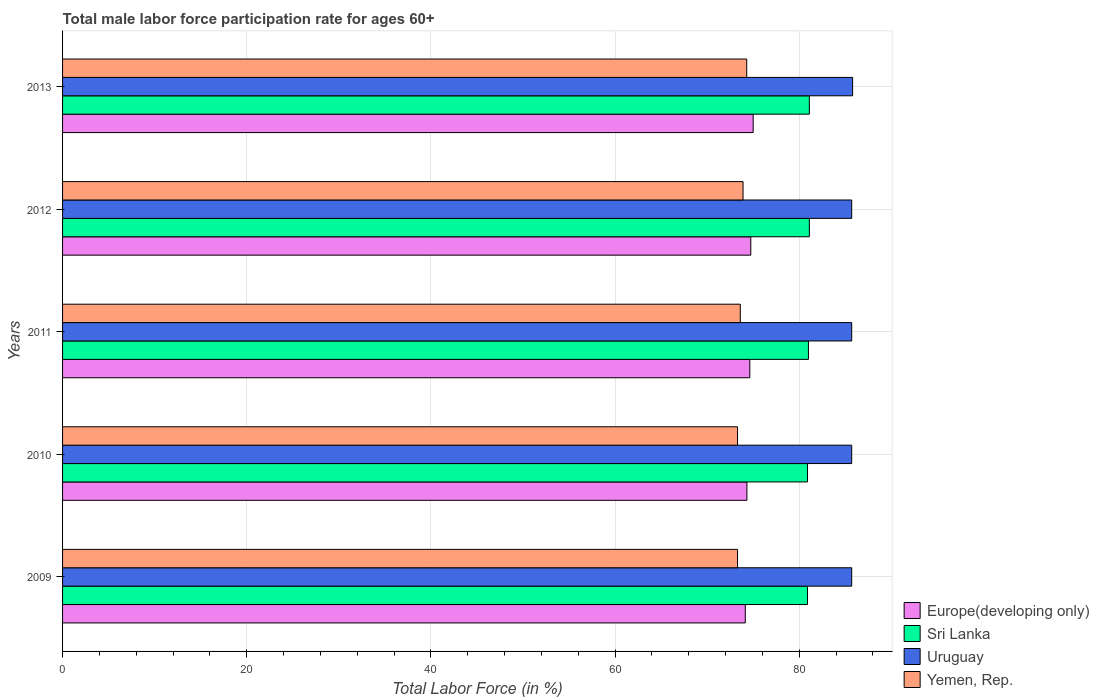How many different coloured bars are there?
Give a very brief answer. 4. How many groups of bars are there?
Provide a short and direct response. 5. How many bars are there on the 2nd tick from the top?
Give a very brief answer. 4. What is the label of the 4th group of bars from the top?
Offer a very short reply. 2010. What is the male labor force participation rate in Yemen, Rep. in 2013?
Keep it short and to the point. 74.3. Across all years, what is the maximum male labor force participation rate in Sri Lanka?
Give a very brief answer. 81.1. Across all years, what is the minimum male labor force participation rate in Uruguay?
Keep it short and to the point. 85.7. In which year was the male labor force participation rate in Europe(developing only) maximum?
Your answer should be compact. 2013. What is the total male labor force participation rate in Yemen, Rep. in the graph?
Make the answer very short. 368.4. What is the difference between the male labor force participation rate in Uruguay in 2010 and that in 2011?
Your answer should be very brief. 0. What is the difference between the male labor force participation rate in Sri Lanka in 2010 and the male labor force participation rate in Yemen, Rep. in 2009?
Make the answer very short. 7.6. What is the average male labor force participation rate in Uruguay per year?
Keep it short and to the point. 85.72. In the year 2010, what is the difference between the male labor force participation rate in Yemen, Rep. and male labor force participation rate in Europe(developing only)?
Keep it short and to the point. -1.02. Is the male labor force participation rate in Europe(developing only) in 2011 less than that in 2013?
Give a very brief answer. Yes. Is the difference between the male labor force participation rate in Yemen, Rep. in 2012 and 2013 greater than the difference between the male labor force participation rate in Europe(developing only) in 2012 and 2013?
Offer a terse response. No. What is the difference between the highest and the second highest male labor force participation rate in Uruguay?
Provide a short and direct response. 0.1. What is the difference between the highest and the lowest male labor force participation rate in Uruguay?
Make the answer very short. 0.1. Is it the case that in every year, the sum of the male labor force participation rate in Yemen, Rep. and male labor force participation rate in Sri Lanka is greater than the sum of male labor force participation rate in Europe(developing only) and male labor force participation rate in Uruguay?
Offer a very short reply. Yes. What does the 3rd bar from the top in 2013 represents?
Give a very brief answer. Sri Lanka. What does the 4th bar from the bottom in 2012 represents?
Offer a very short reply. Yemen, Rep. What is the difference between two consecutive major ticks on the X-axis?
Ensure brevity in your answer.  20. Does the graph contain any zero values?
Offer a terse response. No. What is the title of the graph?
Offer a terse response. Total male labor force participation rate for ages 60+. What is the Total Labor Force (in %) of Europe(developing only) in 2009?
Offer a terse response. 74.14. What is the Total Labor Force (in %) of Sri Lanka in 2009?
Your response must be concise. 80.9. What is the Total Labor Force (in %) in Uruguay in 2009?
Keep it short and to the point. 85.7. What is the Total Labor Force (in %) in Yemen, Rep. in 2009?
Make the answer very short. 73.3. What is the Total Labor Force (in %) of Europe(developing only) in 2010?
Your answer should be compact. 74.32. What is the Total Labor Force (in %) in Sri Lanka in 2010?
Provide a short and direct response. 80.9. What is the Total Labor Force (in %) in Uruguay in 2010?
Your answer should be very brief. 85.7. What is the Total Labor Force (in %) in Yemen, Rep. in 2010?
Ensure brevity in your answer.  73.3. What is the Total Labor Force (in %) of Europe(developing only) in 2011?
Make the answer very short. 74.63. What is the Total Labor Force (in %) in Sri Lanka in 2011?
Your answer should be compact. 81. What is the Total Labor Force (in %) of Uruguay in 2011?
Provide a succinct answer. 85.7. What is the Total Labor Force (in %) in Yemen, Rep. in 2011?
Your answer should be very brief. 73.6. What is the Total Labor Force (in %) of Europe(developing only) in 2012?
Make the answer very short. 74.74. What is the Total Labor Force (in %) of Sri Lanka in 2012?
Your response must be concise. 81.1. What is the Total Labor Force (in %) in Uruguay in 2012?
Your answer should be very brief. 85.7. What is the Total Labor Force (in %) of Yemen, Rep. in 2012?
Provide a short and direct response. 73.9. What is the Total Labor Force (in %) of Europe(developing only) in 2013?
Provide a succinct answer. 75. What is the Total Labor Force (in %) of Sri Lanka in 2013?
Provide a succinct answer. 81.1. What is the Total Labor Force (in %) in Uruguay in 2013?
Make the answer very short. 85.8. What is the Total Labor Force (in %) of Yemen, Rep. in 2013?
Your response must be concise. 74.3. Across all years, what is the maximum Total Labor Force (in %) of Europe(developing only)?
Your answer should be very brief. 75. Across all years, what is the maximum Total Labor Force (in %) of Sri Lanka?
Your response must be concise. 81.1. Across all years, what is the maximum Total Labor Force (in %) of Uruguay?
Keep it short and to the point. 85.8. Across all years, what is the maximum Total Labor Force (in %) of Yemen, Rep.?
Offer a very short reply. 74.3. Across all years, what is the minimum Total Labor Force (in %) in Europe(developing only)?
Make the answer very short. 74.14. Across all years, what is the minimum Total Labor Force (in %) in Sri Lanka?
Give a very brief answer. 80.9. Across all years, what is the minimum Total Labor Force (in %) in Uruguay?
Your answer should be very brief. 85.7. Across all years, what is the minimum Total Labor Force (in %) in Yemen, Rep.?
Make the answer very short. 73.3. What is the total Total Labor Force (in %) of Europe(developing only) in the graph?
Your answer should be very brief. 372.83. What is the total Total Labor Force (in %) of Sri Lanka in the graph?
Make the answer very short. 405. What is the total Total Labor Force (in %) in Uruguay in the graph?
Offer a terse response. 428.6. What is the total Total Labor Force (in %) of Yemen, Rep. in the graph?
Make the answer very short. 368.4. What is the difference between the Total Labor Force (in %) of Europe(developing only) in 2009 and that in 2010?
Your answer should be compact. -0.18. What is the difference between the Total Labor Force (in %) in Yemen, Rep. in 2009 and that in 2010?
Give a very brief answer. 0. What is the difference between the Total Labor Force (in %) of Europe(developing only) in 2009 and that in 2011?
Offer a terse response. -0.49. What is the difference between the Total Labor Force (in %) of Uruguay in 2009 and that in 2011?
Ensure brevity in your answer.  0. What is the difference between the Total Labor Force (in %) of Yemen, Rep. in 2009 and that in 2011?
Give a very brief answer. -0.3. What is the difference between the Total Labor Force (in %) of Europe(developing only) in 2009 and that in 2012?
Ensure brevity in your answer.  -0.6. What is the difference between the Total Labor Force (in %) of Uruguay in 2009 and that in 2012?
Provide a succinct answer. 0. What is the difference between the Total Labor Force (in %) in Yemen, Rep. in 2009 and that in 2012?
Keep it short and to the point. -0.6. What is the difference between the Total Labor Force (in %) of Europe(developing only) in 2009 and that in 2013?
Make the answer very short. -0.86. What is the difference between the Total Labor Force (in %) in Sri Lanka in 2009 and that in 2013?
Your response must be concise. -0.2. What is the difference between the Total Labor Force (in %) of Uruguay in 2009 and that in 2013?
Your answer should be compact. -0.1. What is the difference between the Total Labor Force (in %) of Europe(developing only) in 2010 and that in 2011?
Provide a succinct answer. -0.31. What is the difference between the Total Labor Force (in %) in Uruguay in 2010 and that in 2011?
Offer a very short reply. 0. What is the difference between the Total Labor Force (in %) in Europe(developing only) in 2010 and that in 2012?
Ensure brevity in your answer.  -0.42. What is the difference between the Total Labor Force (in %) in Uruguay in 2010 and that in 2012?
Ensure brevity in your answer.  0. What is the difference between the Total Labor Force (in %) of Europe(developing only) in 2010 and that in 2013?
Offer a very short reply. -0.68. What is the difference between the Total Labor Force (in %) of Sri Lanka in 2010 and that in 2013?
Provide a short and direct response. -0.2. What is the difference between the Total Labor Force (in %) in Uruguay in 2010 and that in 2013?
Make the answer very short. -0.1. What is the difference between the Total Labor Force (in %) in Yemen, Rep. in 2010 and that in 2013?
Your answer should be very brief. -1. What is the difference between the Total Labor Force (in %) of Europe(developing only) in 2011 and that in 2012?
Your answer should be compact. -0.11. What is the difference between the Total Labor Force (in %) of Uruguay in 2011 and that in 2012?
Your response must be concise. 0. What is the difference between the Total Labor Force (in %) of Yemen, Rep. in 2011 and that in 2012?
Your answer should be compact. -0.3. What is the difference between the Total Labor Force (in %) in Europe(developing only) in 2011 and that in 2013?
Give a very brief answer. -0.37. What is the difference between the Total Labor Force (in %) of Europe(developing only) in 2012 and that in 2013?
Provide a succinct answer. -0.26. What is the difference between the Total Labor Force (in %) in Uruguay in 2012 and that in 2013?
Offer a very short reply. -0.1. What is the difference between the Total Labor Force (in %) in Europe(developing only) in 2009 and the Total Labor Force (in %) in Sri Lanka in 2010?
Provide a short and direct response. -6.76. What is the difference between the Total Labor Force (in %) of Europe(developing only) in 2009 and the Total Labor Force (in %) of Uruguay in 2010?
Provide a short and direct response. -11.56. What is the difference between the Total Labor Force (in %) in Europe(developing only) in 2009 and the Total Labor Force (in %) in Yemen, Rep. in 2010?
Your response must be concise. 0.84. What is the difference between the Total Labor Force (in %) in Sri Lanka in 2009 and the Total Labor Force (in %) in Uruguay in 2010?
Your answer should be compact. -4.8. What is the difference between the Total Labor Force (in %) in Uruguay in 2009 and the Total Labor Force (in %) in Yemen, Rep. in 2010?
Make the answer very short. 12.4. What is the difference between the Total Labor Force (in %) in Europe(developing only) in 2009 and the Total Labor Force (in %) in Sri Lanka in 2011?
Ensure brevity in your answer.  -6.86. What is the difference between the Total Labor Force (in %) of Europe(developing only) in 2009 and the Total Labor Force (in %) of Uruguay in 2011?
Offer a very short reply. -11.56. What is the difference between the Total Labor Force (in %) in Europe(developing only) in 2009 and the Total Labor Force (in %) in Yemen, Rep. in 2011?
Give a very brief answer. 0.54. What is the difference between the Total Labor Force (in %) of Europe(developing only) in 2009 and the Total Labor Force (in %) of Sri Lanka in 2012?
Keep it short and to the point. -6.96. What is the difference between the Total Labor Force (in %) in Europe(developing only) in 2009 and the Total Labor Force (in %) in Uruguay in 2012?
Provide a succinct answer. -11.56. What is the difference between the Total Labor Force (in %) in Europe(developing only) in 2009 and the Total Labor Force (in %) in Yemen, Rep. in 2012?
Make the answer very short. 0.24. What is the difference between the Total Labor Force (in %) in Sri Lanka in 2009 and the Total Labor Force (in %) in Uruguay in 2012?
Provide a short and direct response. -4.8. What is the difference between the Total Labor Force (in %) in Sri Lanka in 2009 and the Total Labor Force (in %) in Yemen, Rep. in 2012?
Ensure brevity in your answer.  7. What is the difference between the Total Labor Force (in %) in Europe(developing only) in 2009 and the Total Labor Force (in %) in Sri Lanka in 2013?
Your answer should be compact. -6.96. What is the difference between the Total Labor Force (in %) of Europe(developing only) in 2009 and the Total Labor Force (in %) of Uruguay in 2013?
Your answer should be very brief. -11.66. What is the difference between the Total Labor Force (in %) of Europe(developing only) in 2009 and the Total Labor Force (in %) of Yemen, Rep. in 2013?
Ensure brevity in your answer.  -0.16. What is the difference between the Total Labor Force (in %) of Sri Lanka in 2009 and the Total Labor Force (in %) of Yemen, Rep. in 2013?
Keep it short and to the point. 6.6. What is the difference between the Total Labor Force (in %) of Europe(developing only) in 2010 and the Total Labor Force (in %) of Sri Lanka in 2011?
Provide a short and direct response. -6.68. What is the difference between the Total Labor Force (in %) of Europe(developing only) in 2010 and the Total Labor Force (in %) of Uruguay in 2011?
Offer a very short reply. -11.38. What is the difference between the Total Labor Force (in %) of Europe(developing only) in 2010 and the Total Labor Force (in %) of Yemen, Rep. in 2011?
Offer a very short reply. 0.72. What is the difference between the Total Labor Force (in %) in Sri Lanka in 2010 and the Total Labor Force (in %) in Uruguay in 2011?
Your answer should be compact. -4.8. What is the difference between the Total Labor Force (in %) in Sri Lanka in 2010 and the Total Labor Force (in %) in Yemen, Rep. in 2011?
Offer a terse response. 7.3. What is the difference between the Total Labor Force (in %) in Uruguay in 2010 and the Total Labor Force (in %) in Yemen, Rep. in 2011?
Ensure brevity in your answer.  12.1. What is the difference between the Total Labor Force (in %) in Europe(developing only) in 2010 and the Total Labor Force (in %) in Sri Lanka in 2012?
Your answer should be compact. -6.78. What is the difference between the Total Labor Force (in %) in Europe(developing only) in 2010 and the Total Labor Force (in %) in Uruguay in 2012?
Give a very brief answer. -11.38. What is the difference between the Total Labor Force (in %) in Europe(developing only) in 2010 and the Total Labor Force (in %) in Yemen, Rep. in 2012?
Keep it short and to the point. 0.42. What is the difference between the Total Labor Force (in %) in Sri Lanka in 2010 and the Total Labor Force (in %) in Uruguay in 2012?
Provide a succinct answer. -4.8. What is the difference between the Total Labor Force (in %) in Europe(developing only) in 2010 and the Total Labor Force (in %) in Sri Lanka in 2013?
Your response must be concise. -6.78. What is the difference between the Total Labor Force (in %) of Europe(developing only) in 2010 and the Total Labor Force (in %) of Uruguay in 2013?
Provide a succinct answer. -11.48. What is the difference between the Total Labor Force (in %) of Europe(developing only) in 2010 and the Total Labor Force (in %) of Yemen, Rep. in 2013?
Provide a short and direct response. 0.02. What is the difference between the Total Labor Force (in %) of Europe(developing only) in 2011 and the Total Labor Force (in %) of Sri Lanka in 2012?
Keep it short and to the point. -6.47. What is the difference between the Total Labor Force (in %) of Europe(developing only) in 2011 and the Total Labor Force (in %) of Uruguay in 2012?
Provide a succinct answer. -11.07. What is the difference between the Total Labor Force (in %) of Europe(developing only) in 2011 and the Total Labor Force (in %) of Yemen, Rep. in 2012?
Give a very brief answer. 0.73. What is the difference between the Total Labor Force (in %) of Sri Lanka in 2011 and the Total Labor Force (in %) of Yemen, Rep. in 2012?
Your response must be concise. 7.1. What is the difference between the Total Labor Force (in %) in Uruguay in 2011 and the Total Labor Force (in %) in Yemen, Rep. in 2012?
Your response must be concise. 11.8. What is the difference between the Total Labor Force (in %) of Europe(developing only) in 2011 and the Total Labor Force (in %) of Sri Lanka in 2013?
Give a very brief answer. -6.47. What is the difference between the Total Labor Force (in %) of Europe(developing only) in 2011 and the Total Labor Force (in %) of Uruguay in 2013?
Your answer should be compact. -11.17. What is the difference between the Total Labor Force (in %) in Europe(developing only) in 2011 and the Total Labor Force (in %) in Yemen, Rep. in 2013?
Your answer should be very brief. 0.33. What is the difference between the Total Labor Force (in %) of Sri Lanka in 2011 and the Total Labor Force (in %) of Uruguay in 2013?
Provide a succinct answer. -4.8. What is the difference between the Total Labor Force (in %) of Uruguay in 2011 and the Total Labor Force (in %) of Yemen, Rep. in 2013?
Ensure brevity in your answer.  11.4. What is the difference between the Total Labor Force (in %) of Europe(developing only) in 2012 and the Total Labor Force (in %) of Sri Lanka in 2013?
Your answer should be very brief. -6.36. What is the difference between the Total Labor Force (in %) of Europe(developing only) in 2012 and the Total Labor Force (in %) of Uruguay in 2013?
Offer a very short reply. -11.06. What is the difference between the Total Labor Force (in %) of Europe(developing only) in 2012 and the Total Labor Force (in %) of Yemen, Rep. in 2013?
Ensure brevity in your answer.  0.44. What is the difference between the Total Labor Force (in %) in Sri Lanka in 2012 and the Total Labor Force (in %) in Uruguay in 2013?
Your answer should be very brief. -4.7. What is the difference between the Total Labor Force (in %) of Sri Lanka in 2012 and the Total Labor Force (in %) of Yemen, Rep. in 2013?
Offer a terse response. 6.8. What is the difference between the Total Labor Force (in %) in Uruguay in 2012 and the Total Labor Force (in %) in Yemen, Rep. in 2013?
Offer a very short reply. 11.4. What is the average Total Labor Force (in %) in Europe(developing only) per year?
Provide a short and direct response. 74.57. What is the average Total Labor Force (in %) in Uruguay per year?
Make the answer very short. 85.72. What is the average Total Labor Force (in %) of Yemen, Rep. per year?
Offer a very short reply. 73.68. In the year 2009, what is the difference between the Total Labor Force (in %) in Europe(developing only) and Total Labor Force (in %) in Sri Lanka?
Keep it short and to the point. -6.76. In the year 2009, what is the difference between the Total Labor Force (in %) in Europe(developing only) and Total Labor Force (in %) in Uruguay?
Provide a succinct answer. -11.56. In the year 2009, what is the difference between the Total Labor Force (in %) of Europe(developing only) and Total Labor Force (in %) of Yemen, Rep.?
Your answer should be compact. 0.84. In the year 2009, what is the difference between the Total Labor Force (in %) in Sri Lanka and Total Labor Force (in %) in Yemen, Rep.?
Your answer should be compact. 7.6. In the year 2010, what is the difference between the Total Labor Force (in %) in Europe(developing only) and Total Labor Force (in %) in Sri Lanka?
Provide a succinct answer. -6.58. In the year 2010, what is the difference between the Total Labor Force (in %) in Europe(developing only) and Total Labor Force (in %) in Uruguay?
Make the answer very short. -11.38. In the year 2010, what is the difference between the Total Labor Force (in %) in Europe(developing only) and Total Labor Force (in %) in Yemen, Rep.?
Give a very brief answer. 1.02. In the year 2010, what is the difference between the Total Labor Force (in %) in Uruguay and Total Labor Force (in %) in Yemen, Rep.?
Make the answer very short. 12.4. In the year 2011, what is the difference between the Total Labor Force (in %) in Europe(developing only) and Total Labor Force (in %) in Sri Lanka?
Give a very brief answer. -6.37. In the year 2011, what is the difference between the Total Labor Force (in %) in Europe(developing only) and Total Labor Force (in %) in Uruguay?
Make the answer very short. -11.07. In the year 2011, what is the difference between the Total Labor Force (in %) of Europe(developing only) and Total Labor Force (in %) of Yemen, Rep.?
Make the answer very short. 1.03. In the year 2011, what is the difference between the Total Labor Force (in %) of Sri Lanka and Total Labor Force (in %) of Uruguay?
Your answer should be compact. -4.7. In the year 2011, what is the difference between the Total Labor Force (in %) in Sri Lanka and Total Labor Force (in %) in Yemen, Rep.?
Ensure brevity in your answer.  7.4. In the year 2012, what is the difference between the Total Labor Force (in %) of Europe(developing only) and Total Labor Force (in %) of Sri Lanka?
Offer a very short reply. -6.36. In the year 2012, what is the difference between the Total Labor Force (in %) of Europe(developing only) and Total Labor Force (in %) of Uruguay?
Offer a very short reply. -10.96. In the year 2012, what is the difference between the Total Labor Force (in %) in Europe(developing only) and Total Labor Force (in %) in Yemen, Rep.?
Provide a short and direct response. 0.84. In the year 2012, what is the difference between the Total Labor Force (in %) in Sri Lanka and Total Labor Force (in %) in Yemen, Rep.?
Your response must be concise. 7.2. In the year 2013, what is the difference between the Total Labor Force (in %) of Europe(developing only) and Total Labor Force (in %) of Sri Lanka?
Your answer should be very brief. -6.1. In the year 2013, what is the difference between the Total Labor Force (in %) of Europe(developing only) and Total Labor Force (in %) of Uruguay?
Your answer should be very brief. -10.8. In the year 2013, what is the difference between the Total Labor Force (in %) of Europe(developing only) and Total Labor Force (in %) of Yemen, Rep.?
Offer a terse response. 0.7. In the year 2013, what is the difference between the Total Labor Force (in %) in Sri Lanka and Total Labor Force (in %) in Uruguay?
Make the answer very short. -4.7. In the year 2013, what is the difference between the Total Labor Force (in %) in Sri Lanka and Total Labor Force (in %) in Yemen, Rep.?
Ensure brevity in your answer.  6.8. In the year 2013, what is the difference between the Total Labor Force (in %) in Uruguay and Total Labor Force (in %) in Yemen, Rep.?
Provide a short and direct response. 11.5. What is the ratio of the Total Labor Force (in %) of Europe(developing only) in 2009 to that in 2010?
Provide a short and direct response. 1. What is the ratio of the Total Labor Force (in %) in Yemen, Rep. in 2009 to that in 2010?
Your answer should be very brief. 1. What is the ratio of the Total Labor Force (in %) in Sri Lanka in 2009 to that in 2011?
Provide a short and direct response. 1. What is the ratio of the Total Labor Force (in %) of Yemen, Rep. in 2009 to that in 2011?
Your answer should be compact. 1. What is the ratio of the Total Labor Force (in %) in Yemen, Rep. in 2009 to that in 2012?
Keep it short and to the point. 0.99. What is the ratio of the Total Labor Force (in %) of Europe(developing only) in 2009 to that in 2013?
Keep it short and to the point. 0.99. What is the ratio of the Total Labor Force (in %) in Sri Lanka in 2009 to that in 2013?
Ensure brevity in your answer.  1. What is the ratio of the Total Labor Force (in %) in Yemen, Rep. in 2009 to that in 2013?
Offer a terse response. 0.99. What is the ratio of the Total Labor Force (in %) in Yemen, Rep. in 2010 to that in 2011?
Offer a terse response. 1. What is the ratio of the Total Labor Force (in %) of Europe(developing only) in 2010 to that in 2012?
Offer a terse response. 0.99. What is the ratio of the Total Labor Force (in %) in Sri Lanka in 2010 to that in 2012?
Keep it short and to the point. 1. What is the ratio of the Total Labor Force (in %) of Uruguay in 2010 to that in 2012?
Keep it short and to the point. 1. What is the ratio of the Total Labor Force (in %) in Europe(developing only) in 2010 to that in 2013?
Ensure brevity in your answer.  0.99. What is the ratio of the Total Labor Force (in %) of Uruguay in 2010 to that in 2013?
Provide a short and direct response. 1. What is the ratio of the Total Labor Force (in %) in Yemen, Rep. in 2010 to that in 2013?
Keep it short and to the point. 0.99. What is the ratio of the Total Labor Force (in %) of Europe(developing only) in 2011 to that in 2012?
Give a very brief answer. 1. What is the ratio of the Total Labor Force (in %) in Sri Lanka in 2011 to that in 2012?
Give a very brief answer. 1. What is the ratio of the Total Labor Force (in %) of Uruguay in 2011 to that in 2012?
Keep it short and to the point. 1. What is the ratio of the Total Labor Force (in %) in Europe(developing only) in 2011 to that in 2013?
Keep it short and to the point. 1. What is the ratio of the Total Labor Force (in %) in Sri Lanka in 2011 to that in 2013?
Offer a terse response. 1. What is the ratio of the Total Labor Force (in %) of Yemen, Rep. in 2011 to that in 2013?
Provide a short and direct response. 0.99. What is the ratio of the Total Labor Force (in %) in Yemen, Rep. in 2012 to that in 2013?
Offer a terse response. 0.99. What is the difference between the highest and the second highest Total Labor Force (in %) in Europe(developing only)?
Ensure brevity in your answer.  0.26. What is the difference between the highest and the second highest Total Labor Force (in %) in Sri Lanka?
Your answer should be compact. 0. What is the difference between the highest and the lowest Total Labor Force (in %) of Europe(developing only)?
Keep it short and to the point. 0.86. 